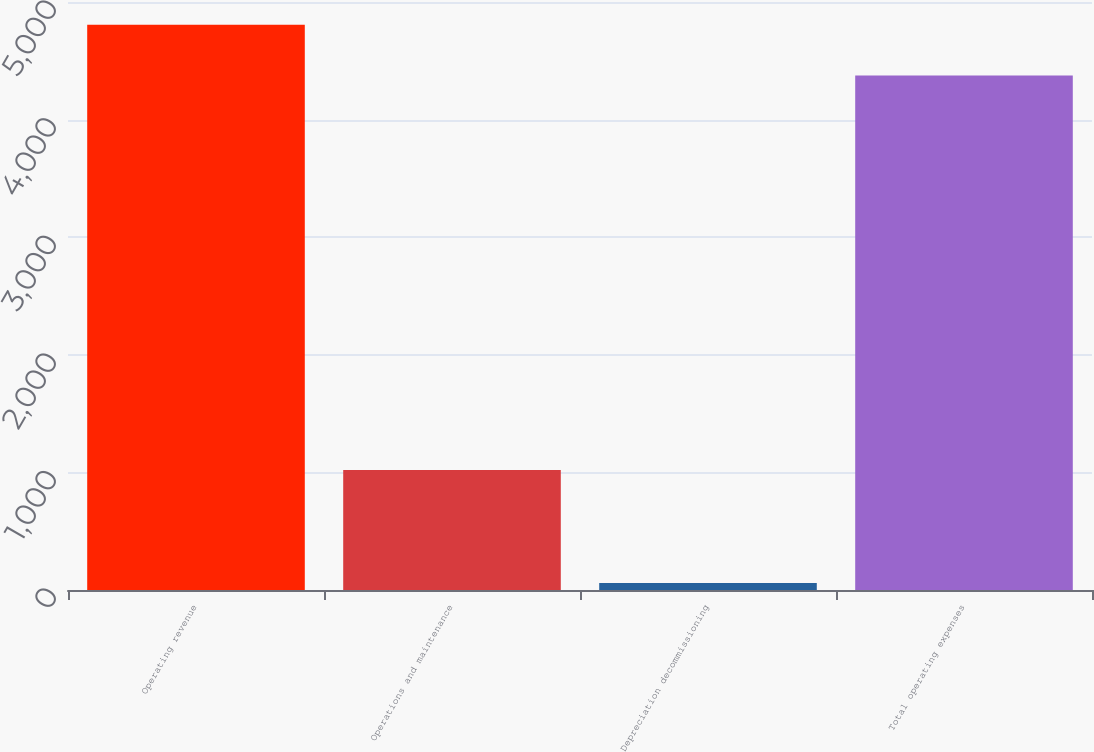Convert chart to OTSL. <chart><loc_0><loc_0><loc_500><loc_500><bar_chart><fcel>Operating revenue<fcel>Operations and maintenance<fcel>Depreciation decommissioning<fcel>Total operating expenses<nl><fcel>4806.7<fcel>1020<fcel>60<fcel>4375<nl></chart> 